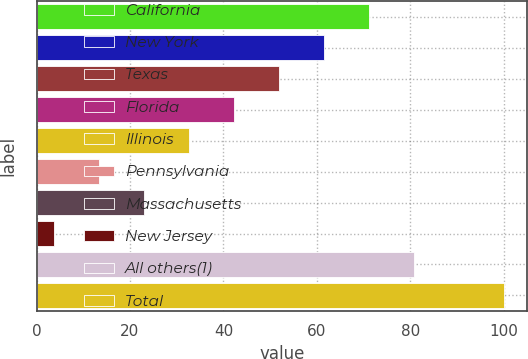<chart> <loc_0><loc_0><loc_500><loc_500><bar_chart><fcel>California<fcel>New York<fcel>Texas<fcel>Florida<fcel>Illinois<fcel>Pennsylvania<fcel>Massachusetts<fcel>New Jersey<fcel>All others(1)<fcel>Total<nl><fcel>71.14<fcel>61.52<fcel>51.9<fcel>42.28<fcel>32.66<fcel>13.42<fcel>23.04<fcel>3.8<fcel>80.76<fcel>100<nl></chart> 